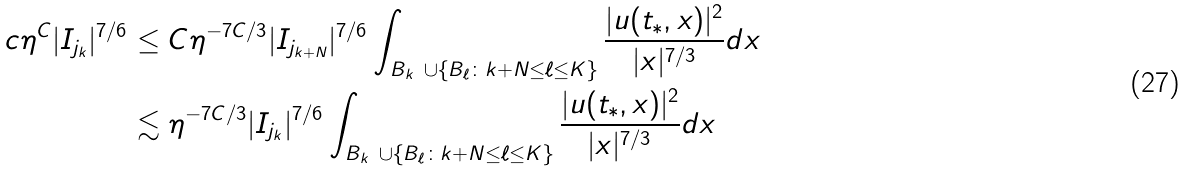Convert formula to latex. <formula><loc_0><loc_0><loc_500><loc_500>c \eta ^ { C } | I _ { j _ { k } } | ^ { 7 / 6 } & \leq C \eta ^ { - 7 C / 3 } | I _ { j _ { k + N } } | ^ { 7 / 6 } \int _ { B _ { k } \ \cup \{ B _ { \ell } \colon k + N \leq \ell \leq K \} } \frac { | u ( t _ { * } , x ) | ^ { 2 } } { | x | ^ { 7 / 3 } } d x \\ & \lesssim \eta ^ { - 7 C / 3 } | I _ { j _ { k } } | ^ { 7 / 6 } \int _ { B _ { k } \ \cup \{ B _ { \ell } \colon k + N \leq \ell \leq K \} } \frac { | u ( t _ { * } , x ) | ^ { 2 } } { | x | ^ { 7 / 3 } } d x</formula> 